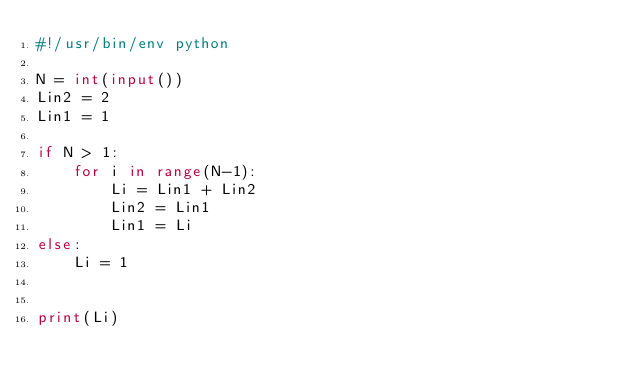<code> <loc_0><loc_0><loc_500><loc_500><_Python_>#!/usr/bin/env python

N = int(input())
Lin2 = 2
Lin1 = 1

if N > 1:
    for i in range(N-1):
        Li = Lin1 + Lin2
        Lin2 = Lin1
        Lin1 = Li
else:
    Li = 1

        
print(Li)
</code> 